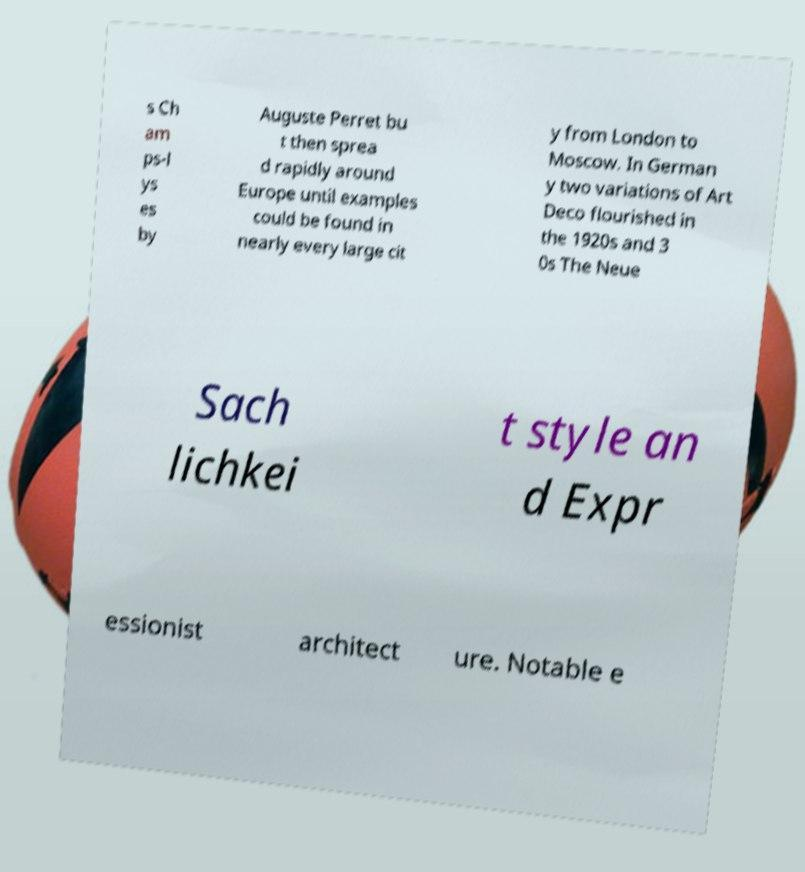Please identify and transcribe the text found in this image. s Ch am ps-l ys es by Auguste Perret bu t then sprea d rapidly around Europe until examples could be found in nearly every large cit y from London to Moscow. In German y two variations of Art Deco flourished in the 1920s and 3 0s The Neue Sach lichkei t style an d Expr essionist architect ure. Notable e 